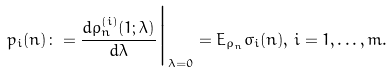Convert formula to latex. <formula><loc_0><loc_0><loc_500><loc_500>p _ { i } ( n ) \colon = \frac { d \rho _ { n } ^ { ( i ) } ( 1 ; \lambda ) } { d \lambda } \Big | _ { \lambda = 0 } = E _ { \rho _ { n } } \sigma _ { i } ( n ) , \, i = 1 , \dots , m .</formula> 